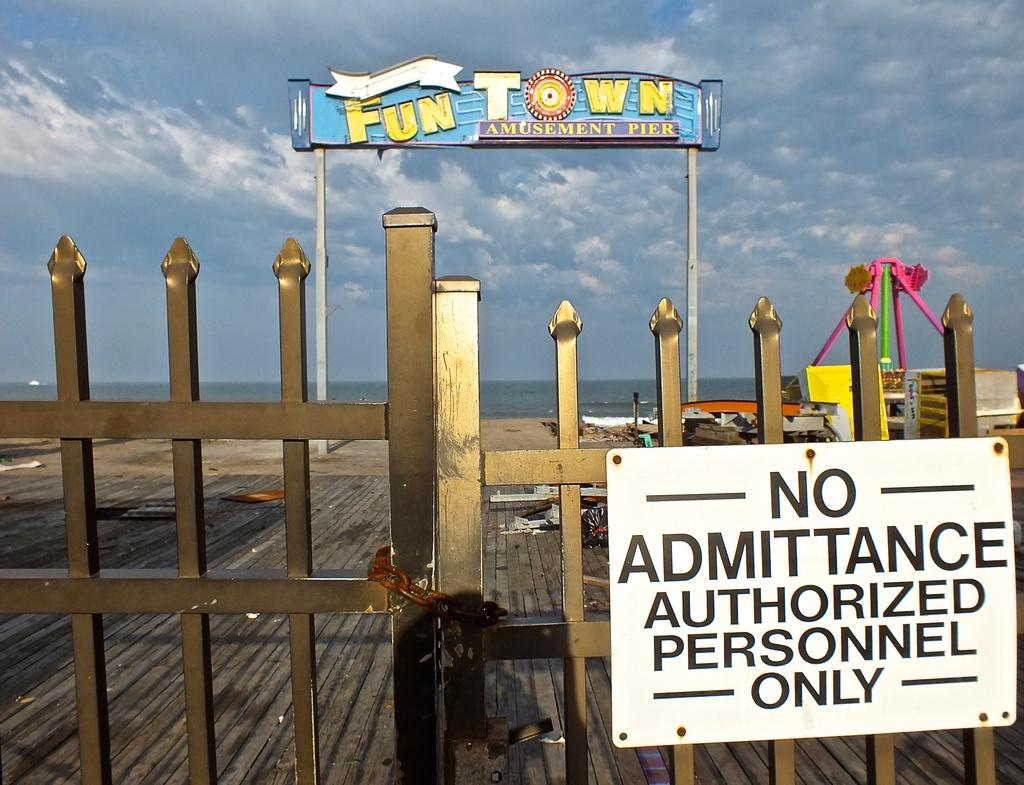<image>
Summarize the visual content of the image. A closed down Fun Town with a sign that says Autorized Personnel Only. 